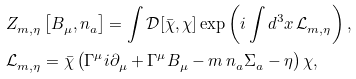Convert formula to latex. <formula><loc_0><loc_0><loc_500><loc_500>& Z ^ { \ } _ { m , \eta } \left [ B ^ { \ } _ { \mu } , n ^ { \ } _ { a } \right ] = \int \mathcal { D } [ \bar { \chi } , \chi ] \exp \left ( { i } \int d ^ { 3 } x \, \mathcal { L } ^ { \ } _ { m , \eta } \right ) , \\ & \mathcal { L } ^ { \ } _ { m , \eta } = \bar { \chi } \left ( \Gamma ^ { \mu } { i } \partial ^ { \ } _ { \mu } + \Gamma ^ { \mu } B ^ { \ } _ { \mu } - m \, n ^ { \ } _ { a } \Sigma ^ { \ } _ { a } - \eta \right ) \chi ,</formula> 